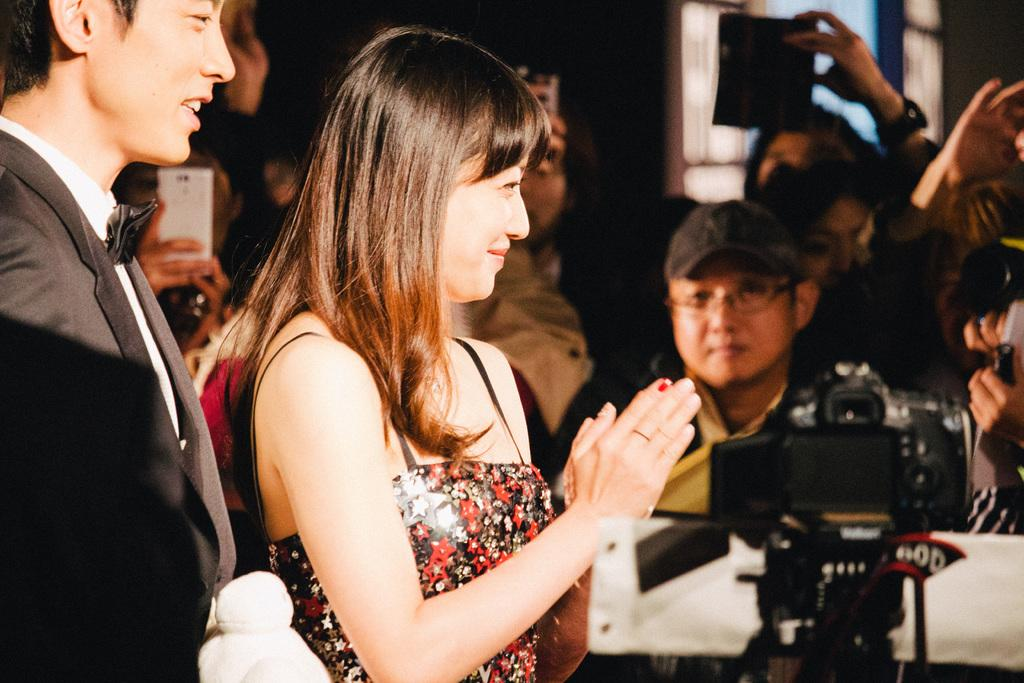What is the main subject of the image? The main subject of the image is a group of people. What object related to photography can be seen in the image? There is a camera with a stand in the bottom right side of the image. How would you describe the background of the image? The background of the image is blurred. What type of celery can be seen growing in the background of the image? There is no celery present in the image; the background is blurred and does not show any plants or vegetation. 